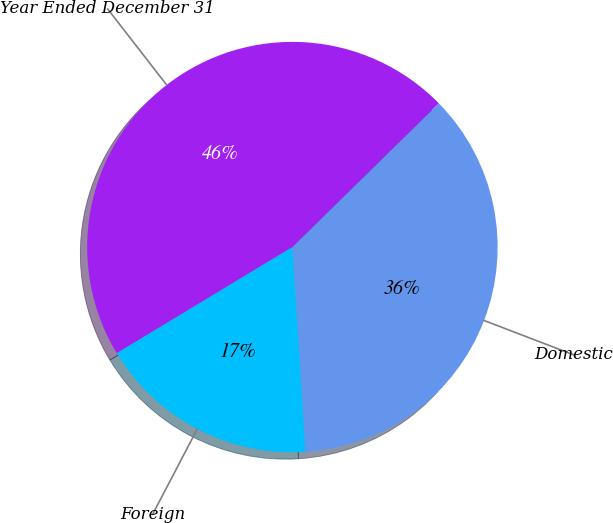Convert chart to OTSL. <chart><loc_0><loc_0><loc_500><loc_500><pie_chart><fcel>Year Ended December 31<fcel>Domestic<fcel>Foreign<nl><fcel>46.3%<fcel>36.34%<fcel>17.36%<nl></chart> 